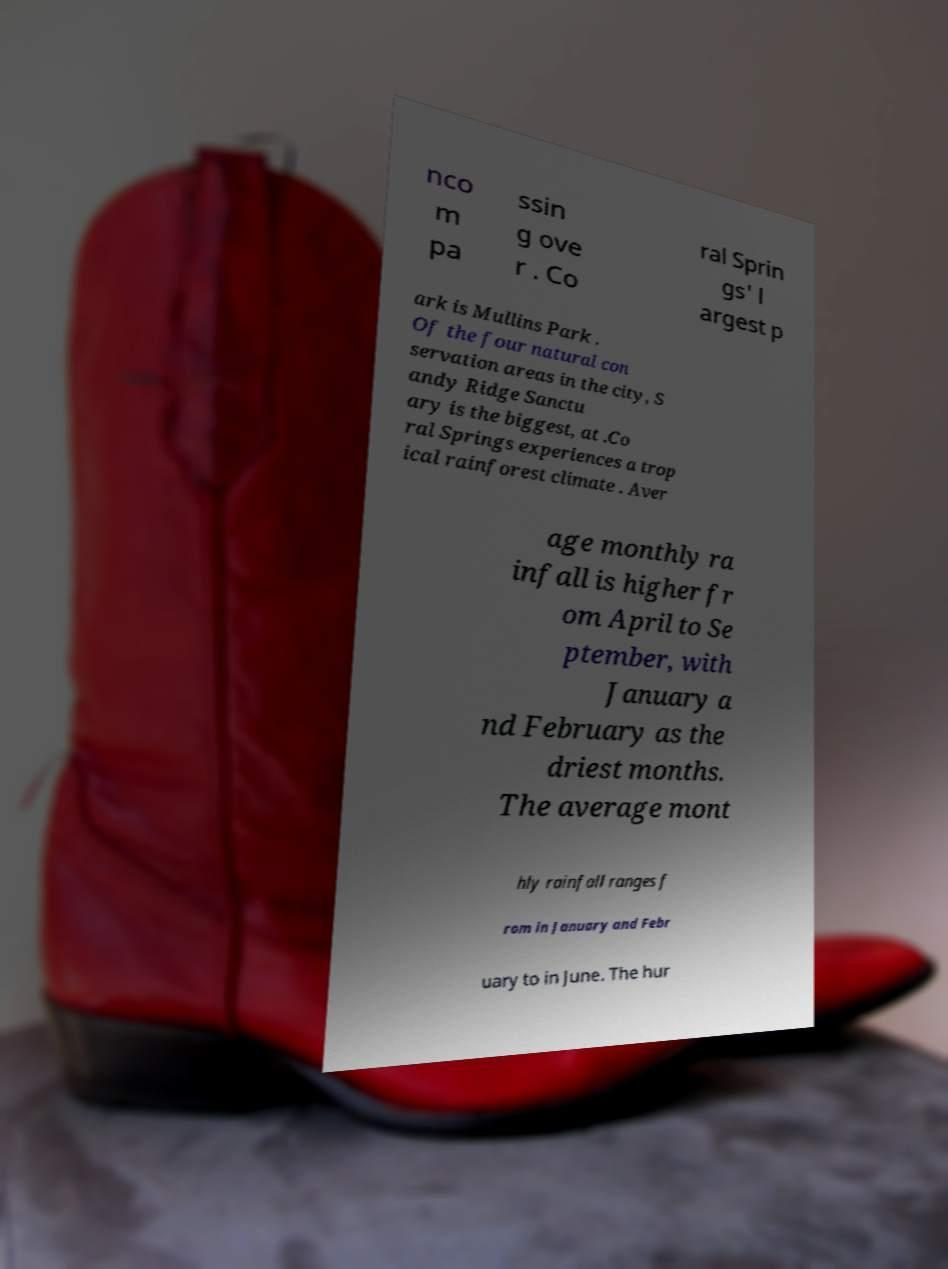Could you extract and type out the text from this image? nco m pa ssin g ove r . Co ral Sprin gs' l argest p ark is Mullins Park . Of the four natural con servation areas in the city, S andy Ridge Sanctu ary is the biggest, at .Co ral Springs experiences a trop ical rainforest climate . Aver age monthly ra infall is higher fr om April to Se ptember, with January a nd February as the driest months. The average mont hly rainfall ranges f rom in January and Febr uary to in June. The hur 